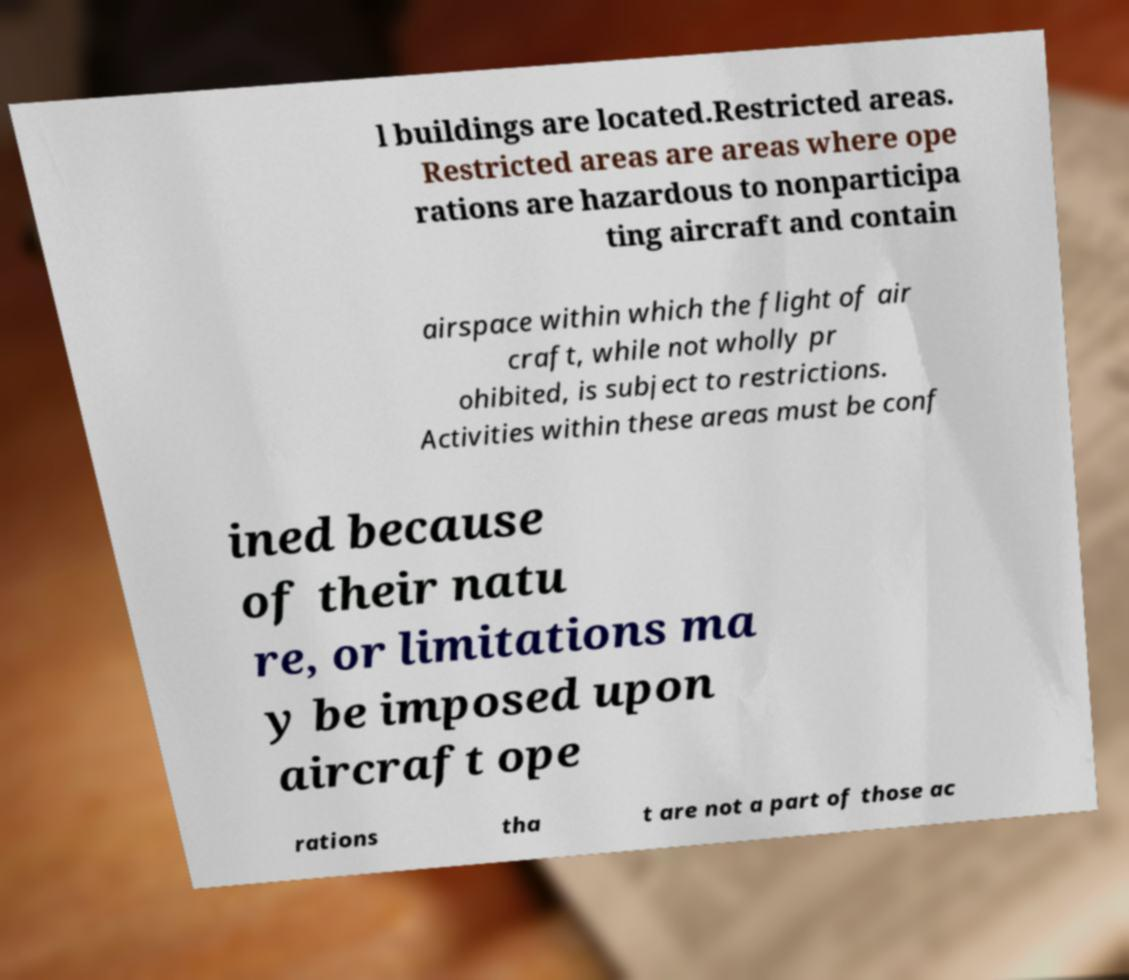Please identify and transcribe the text found in this image. l buildings are located.Restricted areas. Restricted areas are areas where ope rations are hazardous to nonparticipa ting aircraft and contain airspace within which the flight of air craft, while not wholly pr ohibited, is subject to restrictions. Activities within these areas must be conf ined because of their natu re, or limitations ma y be imposed upon aircraft ope rations tha t are not a part of those ac 